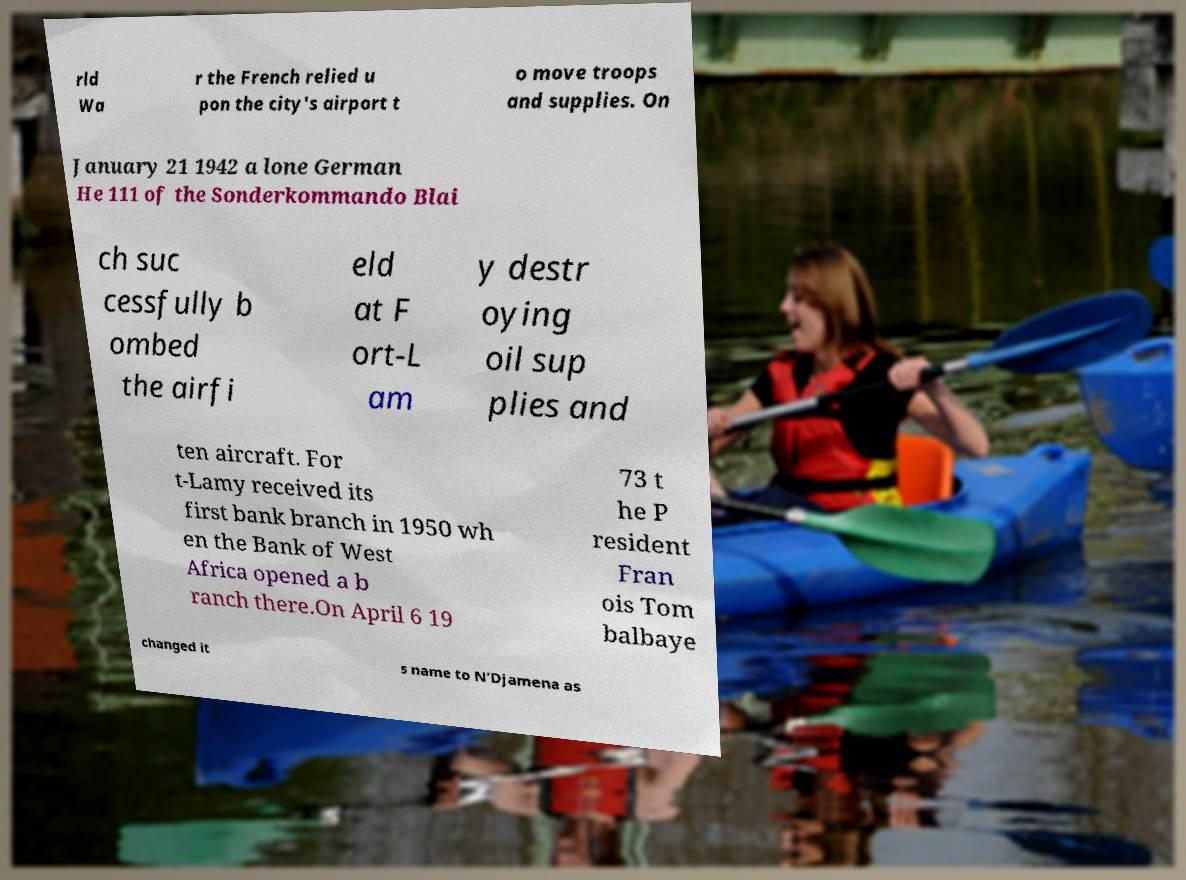Can you accurately transcribe the text from the provided image for me? rld Wa r the French relied u pon the city's airport t o move troops and supplies. On January 21 1942 a lone German He 111 of the Sonderkommando Blai ch suc cessfully b ombed the airfi eld at F ort-L am y destr oying oil sup plies and ten aircraft. For t-Lamy received its first bank branch in 1950 wh en the Bank of West Africa opened a b ranch there.On April 6 19 73 t he P resident Fran ois Tom balbaye changed it s name to N’Djamena as 